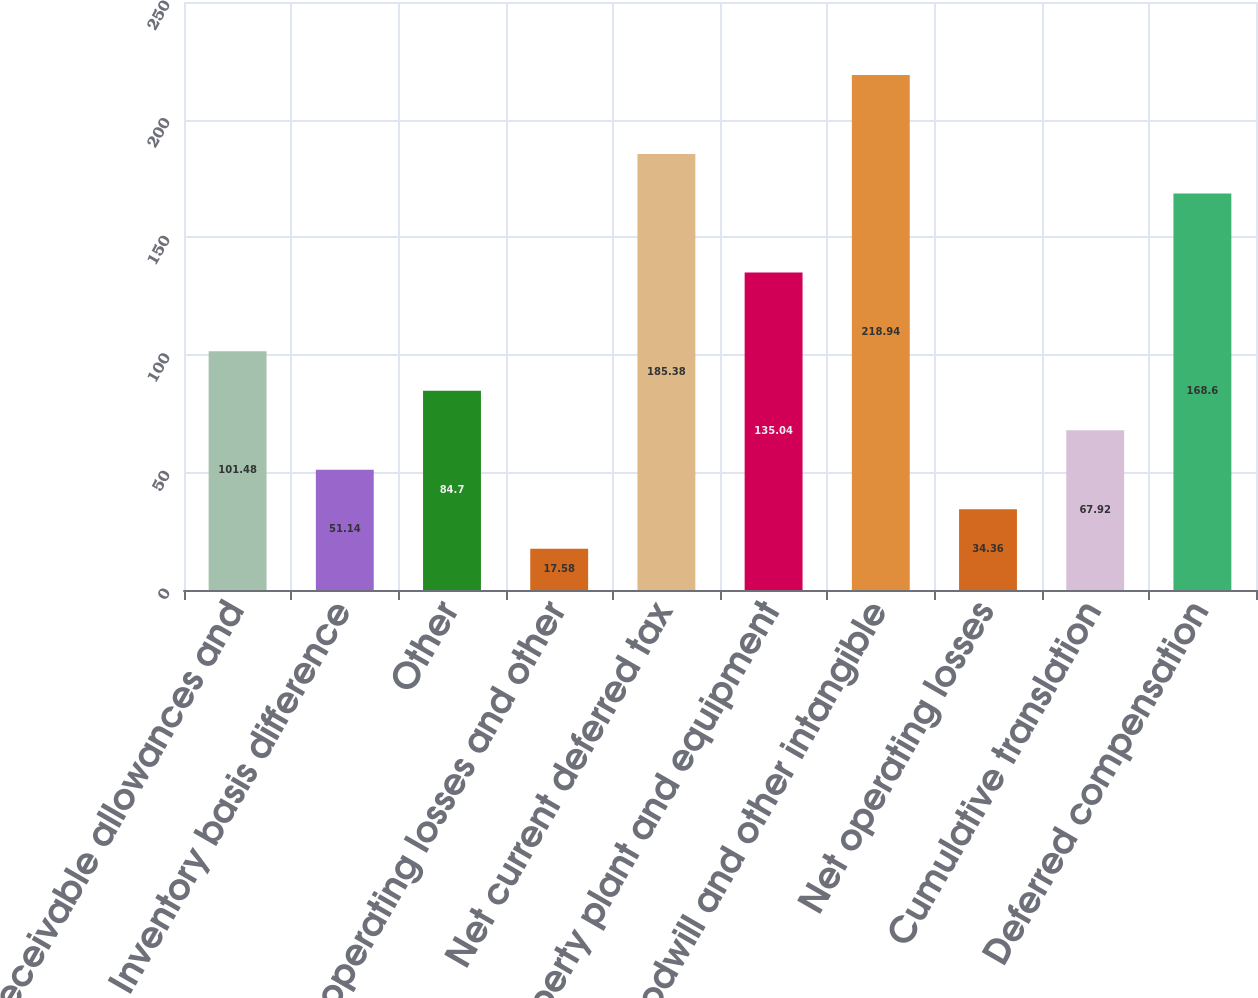Convert chart. <chart><loc_0><loc_0><loc_500><loc_500><bar_chart><fcel>Receivable allowances and<fcel>Inventory basis difference<fcel>Other<fcel>Net operating losses and other<fcel>Net current deferred tax<fcel>Property plant and equipment<fcel>Goodwill and other intangible<fcel>Net operating losses<fcel>Cumulative translation<fcel>Deferred compensation<nl><fcel>101.48<fcel>51.14<fcel>84.7<fcel>17.58<fcel>185.38<fcel>135.04<fcel>218.94<fcel>34.36<fcel>67.92<fcel>168.6<nl></chart> 